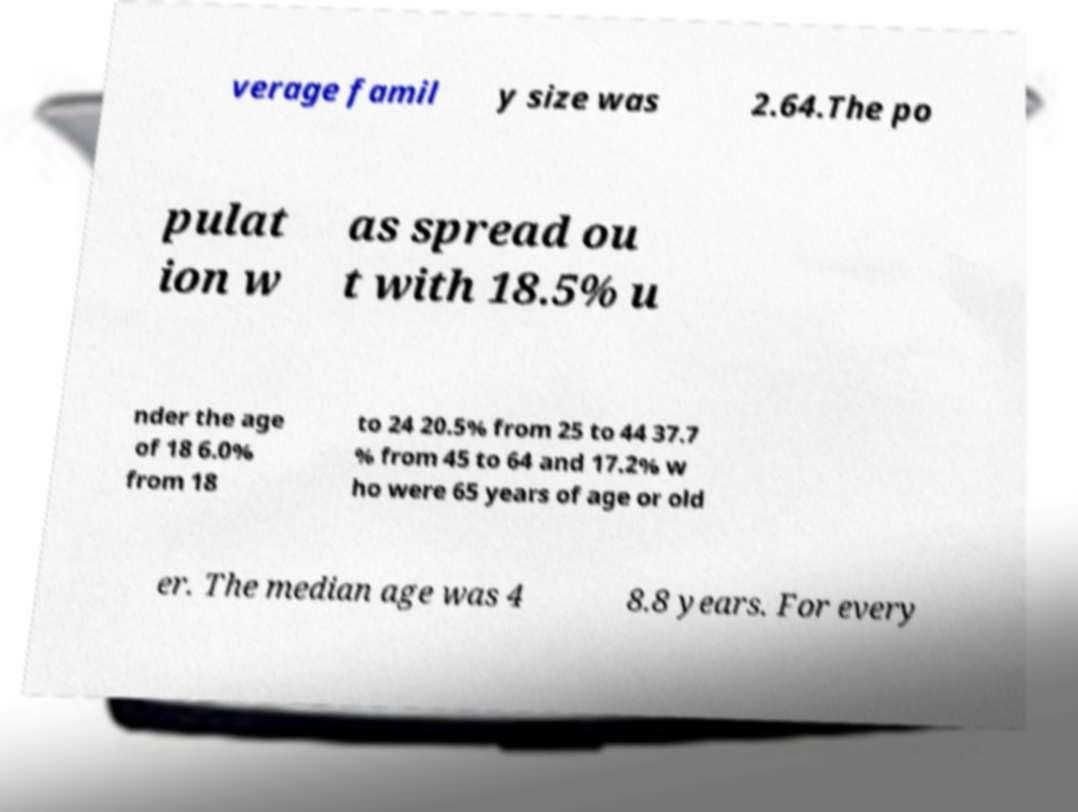Could you extract and type out the text from this image? verage famil y size was 2.64.The po pulat ion w as spread ou t with 18.5% u nder the age of 18 6.0% from 18 to 24 20.5% from 25 to 44 37.7 % from 45 to 64 and 17.2% w ho were 65 years of age or old er. The median age was 4 8.8 years. For every 